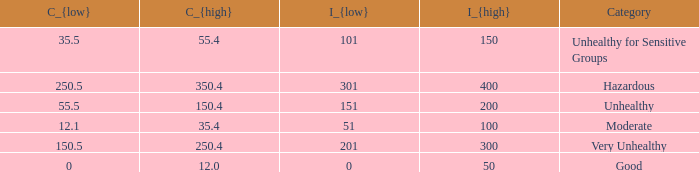What's the i_{high} value when C_{low} is 250.5? 400.0. 